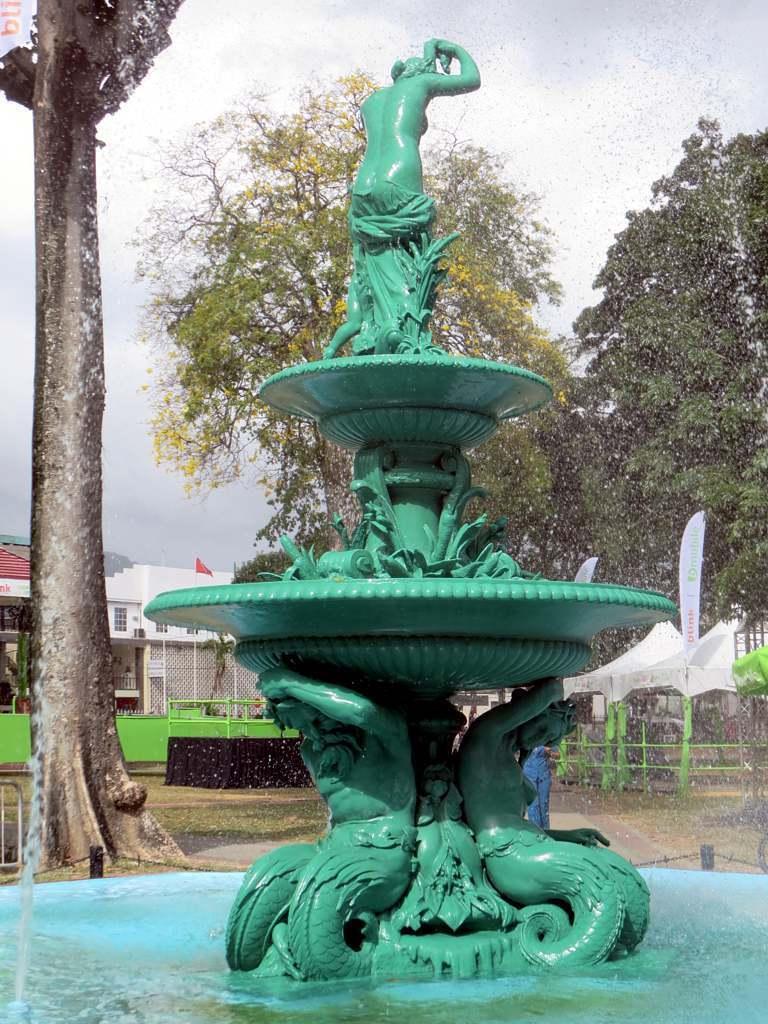Could you give a brief overview of what you see in this image? In this picture I can see the fountain in front, on which there are sculptures and I can see the water. In the background I can see the trees, few buildings, grass, white color things and the sky. 